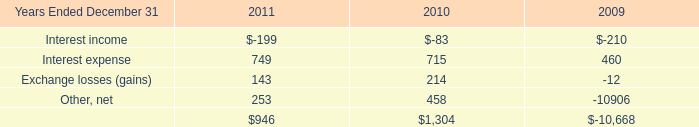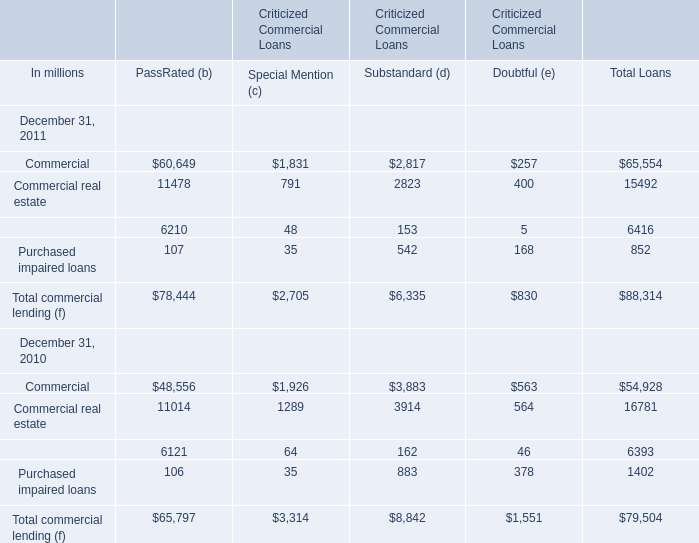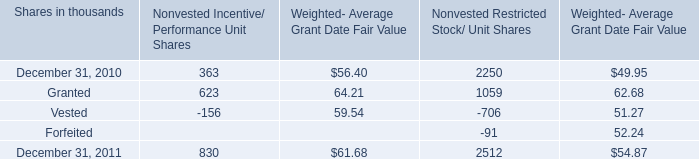what was the percentage change in the total fair value of incentive/performance unit share and restricted stock/unit awards from 2010 to 2011, 
Computations: ((52 + 39) / 39)
Answer: 2.33333. 